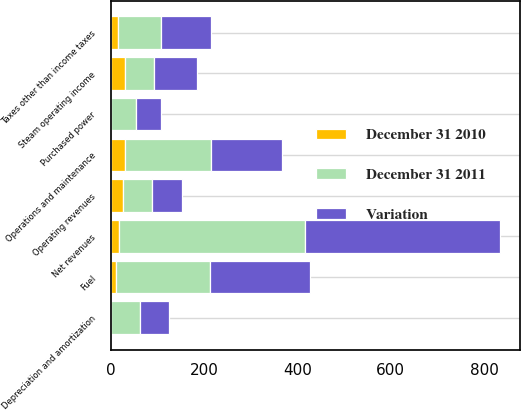Convert chart. <chart><loc_0><loc_0><loc_500><loc_500><stacked_bar_chart><ecel><fcel>Operating revenues<fcel>Purchased power<fcel>Fuel<fcel>Net revenues<fcel>Operations and maintenance<fcel>Depreciation and amortization<fcel>Taxes other than income taxes<fcel>Steam operating income<nl><fcel>Variation<fcel>62.5<fcel>53<fcel>213<fcel>417<fcel>154<fcel>63<fcel>107<fcel>93<nl><fcel>December 31 2011<fcel>62.5<fcel>54<fcel>202<fcel>400<fcel>184<fcel>62<fcel>91<fcel>63<nl><fcel>December 31 2010<fcel>27<fcel>1<fcel>11<fcel>17<fcel>30<fcel>1<fcel>16<fcel>30<nl></chart> 